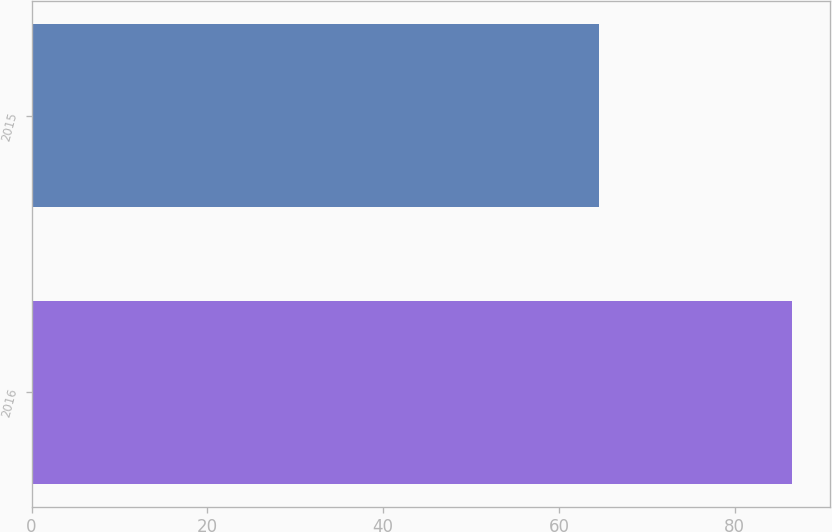Convert chart. <chart><loc_0><loc_0><loc_500><loc_500><bar_chart><fcel>2016<fcel>2015<nl><fcel>86.5<fcel>64.59<nl></chart> 